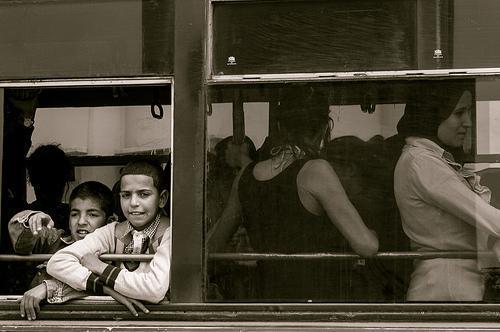How many windows are there?
Give a very brief answer. 2. 